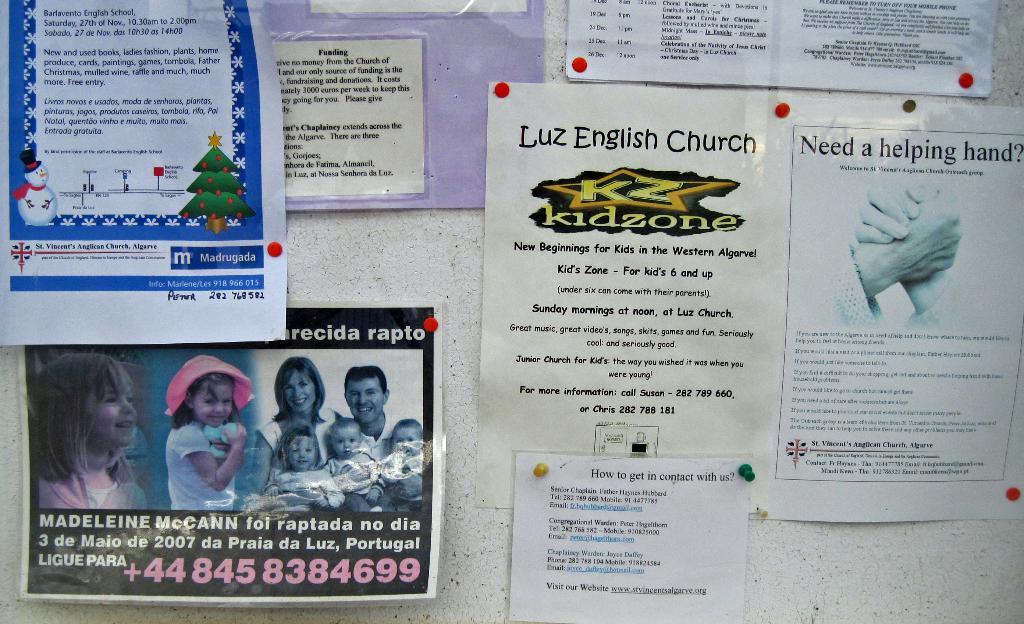What is the name of the church that does the kidzone?
Provide a succinct answer. Luz english church. What is the phone number in pink?
Provide a succinct answer. 448458384699. 